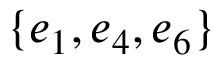Convert formula to latex. <formula><loc_0><loc_0><loc_500><loc_500>\{ e _ { 1 } , e _ { 4 } , e _ { 6 } \}</formula> 